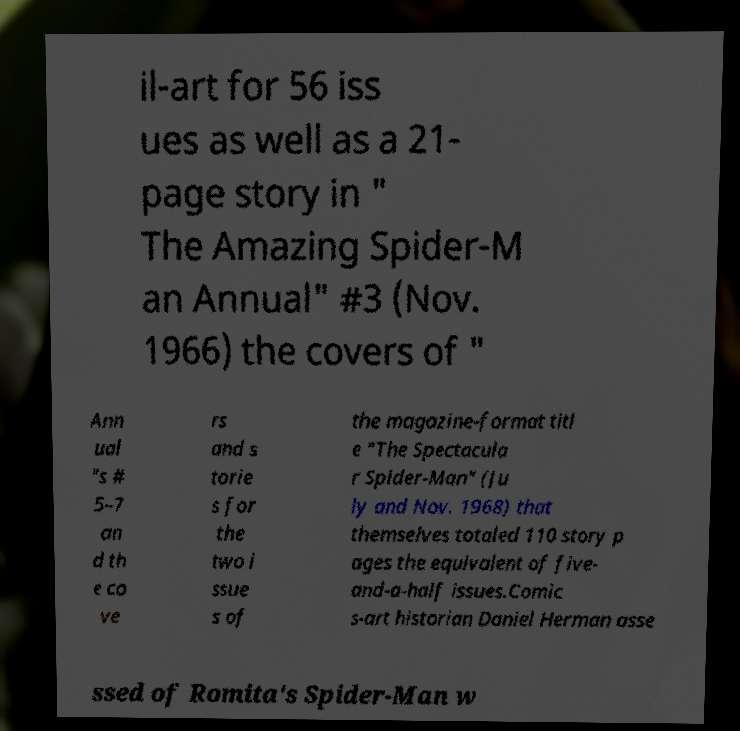Can you read and provide the text displayed in the image?This photo seems to have some interesting text. Can you extract and type it out for me? il-art for 56 iss ues as well as a 21- page story in " The Amazing Spider-M an Annual" #3 (Nov. 1966) the covers of " Ann ual "s # 5–7 an d th e co ve rs and s torie s for the two i ssue s of the magazine-format titl e "The Spectacula r Spider-Man" (Ju ly and Nov. 1968) that themselves totaled 110 story p ages the equivalent of five- and-a-half issues.Comic s-art historian Daniel Herman asse ssed of Romita's Spider-Man w 